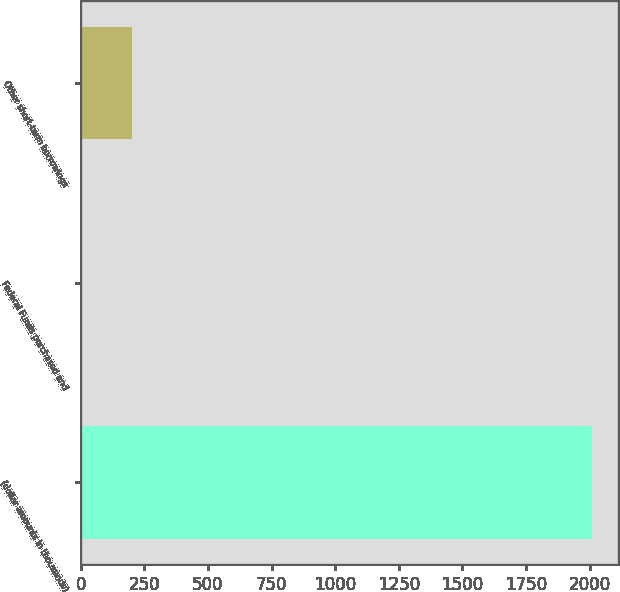<chart> <loc_0><loc_0><loc_500><loc_500><bar_chart><fcel>(dollar amounts in thousands)<fcel>Federal Funds purchased and<fcel>Other short-term borrowings<nl><fcel>2011<fcel>0.17<fcel>201.25<nl></chart> 